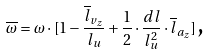<formula> <loc_0><loc_0><loc_500><loc_500>\overline { \omega } = \omega \cdot [ 1 - \frac { \overline { l } _ { v _ { z } } } { l _ { u } } + \frac { 1 } { 2 } \cdot \frac { d l } { l _ { u } ^ { 2 } } \cdot \overline { l } _ { a _ { z } } ] \, \text {,}</formula> 